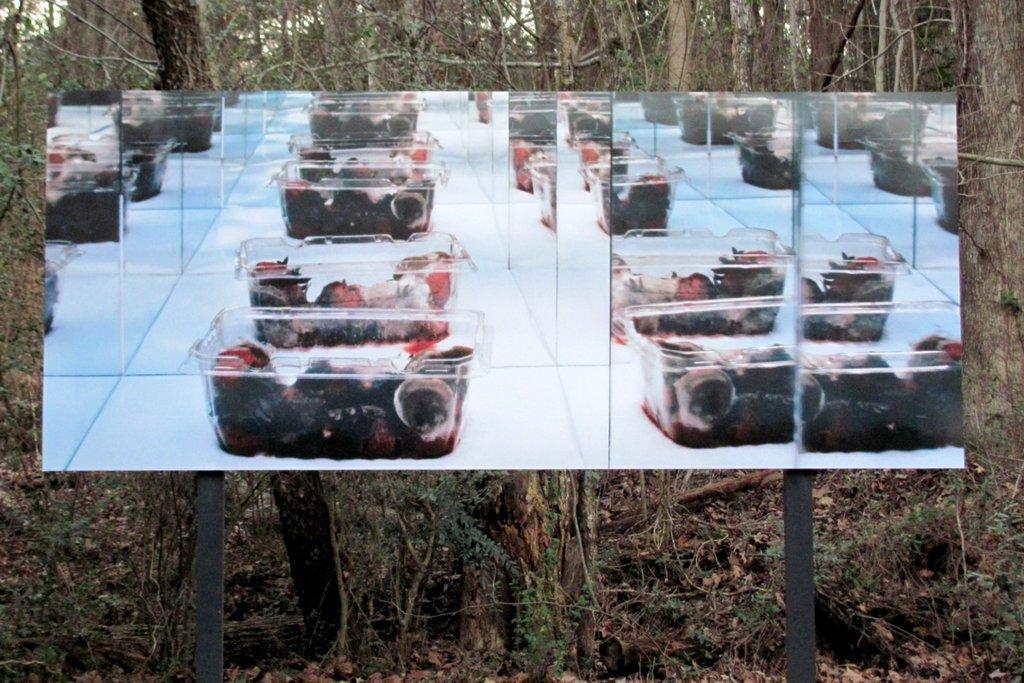How would you summarize this image in a sentence or two? In this picture we can see board on poles, on this board we can see boxes with fruits. In the background of the image we can see trees. 